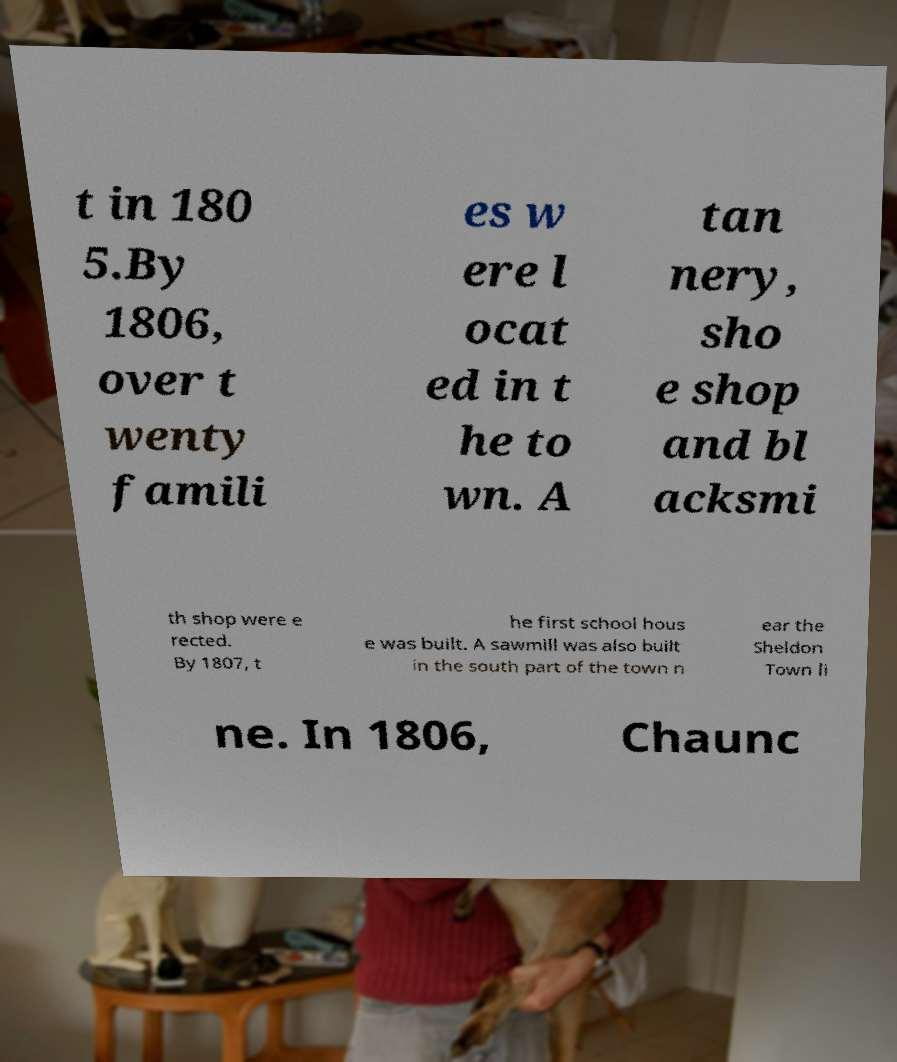Please read and relay the text visible in this image. What does it say? t in 180 5.By 1806, over t wenty famili es w ere l ocat ed in t he to wn. A tan nery, sho e shop and bl acksmi th shop were e rected. By 1807, t he first school hous e was built. A sawmill was also built in the south part of the town n ear the Sheldon Town li ne. In 1806, Chaunc 